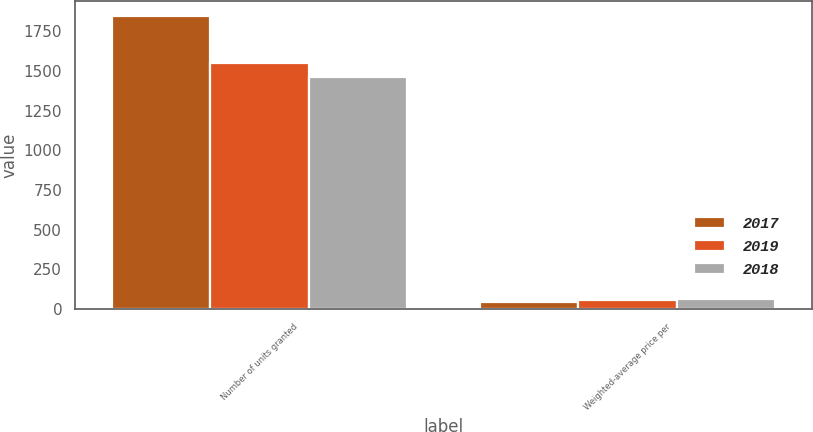Convert chart. <chart><loc_0><loc_0><loc_500><loc_500><stacked_bar_chart><ecel><fcel>Number of units granted<fcel>Weighted-average price per<nl><fcel>2017<fcel>1848.2<fcel>46.14<nl><fcel>2019<fcel>1551.3<fcel>55.12<nl><fcel>2018<fcel>1462.3<fcel>67.01<nl></chart> 